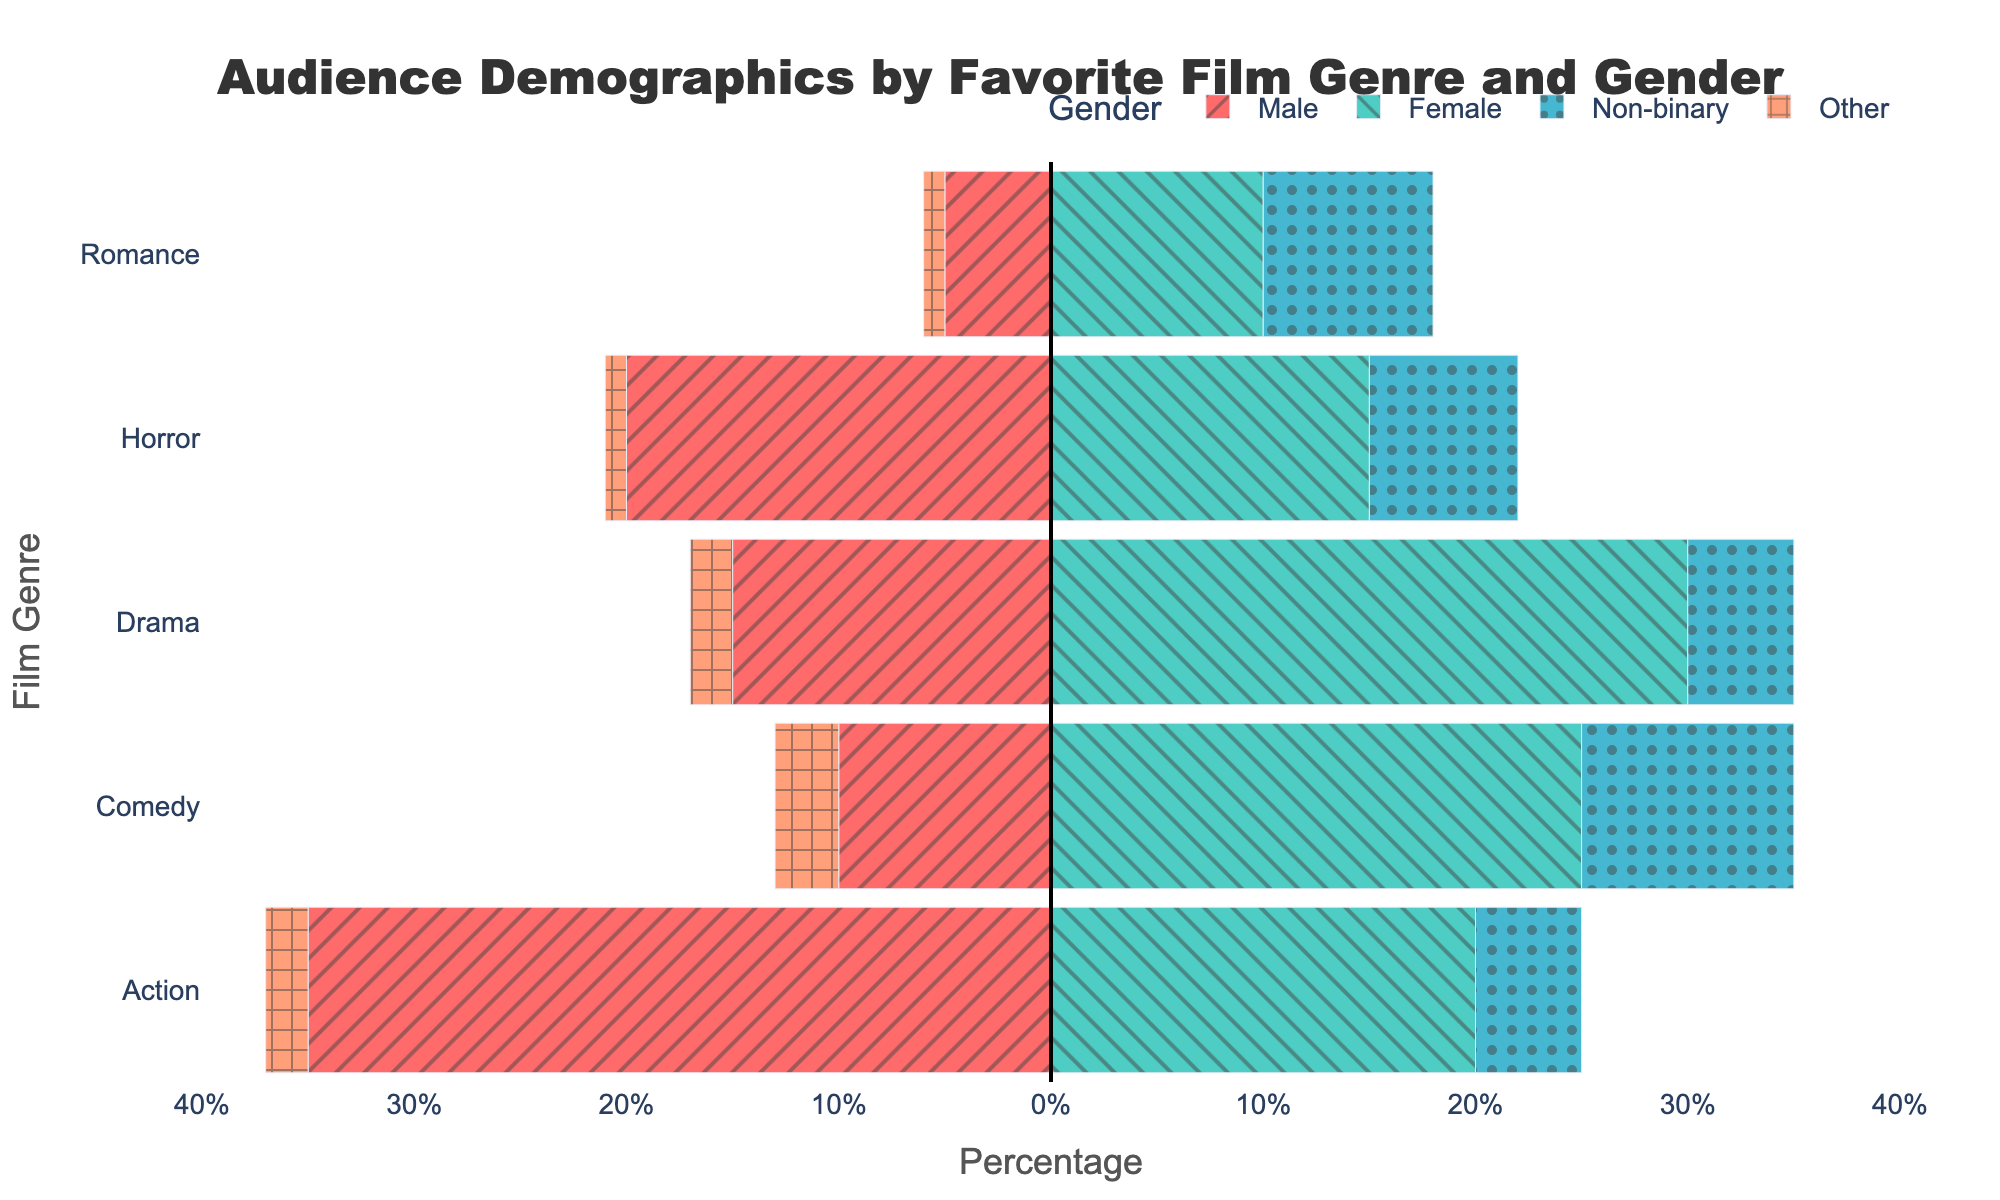Which genre has the highest percentage of male audience? Observing the leftmost bars on the plot (negative values) for each genre, the longest bar corresponds to the “Action” genre at 35%.
Answer: Action Which genre has the highest percentage of female audience? Observing the rightmost bars on the plot (positive values) for each genre, the longest bar corresponds to the "Drama" genre at 30%.
Answer: Drama In which genre is the percentage of non-binary audience the highest? By comparing the yellow bars with dots for non-binary, “Romance” has the highest percentage at 8%.
Answer: Romance Compare the preferences of males and females for the Comedy genre. Which gender has a higher percentage, and by how much? The percentage for males is 10%, for females is 25%. The difference is 25% - 10% = 15%, with females having a higher percentage.
Answer: Females, 15% Which genre shows the least percentage of female audience? The shortest positive bar for females is in the "Romance" genre with 10%.
Answer: Romance What is the total percentage of the male and female audience combined for the Drama genre? Summing the male (15%) and female (30%) percentages for Drama, we get 15% + 30% = 45%.
Answer: 45% Which genre has the highest percentage of audiences identified as Other? Comparing the bars with horizontal lines, for "Comedy" the percentage is 3%, which is the highest for Other.
Answer: Comedy Which genre has the closest percentage of male and female audiences? By finding the smallest difference between male and female percentages, “Horror” has 20% male and 15% female, difference is 5%.
Answer: Horror If you sum up the percentages for all genders in the Action genre, what would it be? Adding the percentages for all genders in Action: 35% (Male) + 20% (Female) + 5% (Non-binary) + 2% (Other) = 62%.
Answer: 62% Between Drama and Horror genres, which has a higher total percentage for non-binary and Other combined, and by how much? Drama has non-binary 5% and Other 2%, total = 7%. Horror has non-binary 7% and Other 1%, total = 8%. Difference = 8% - 7% = 1%, with Horror having higher.
Answer: Horror, 1% 